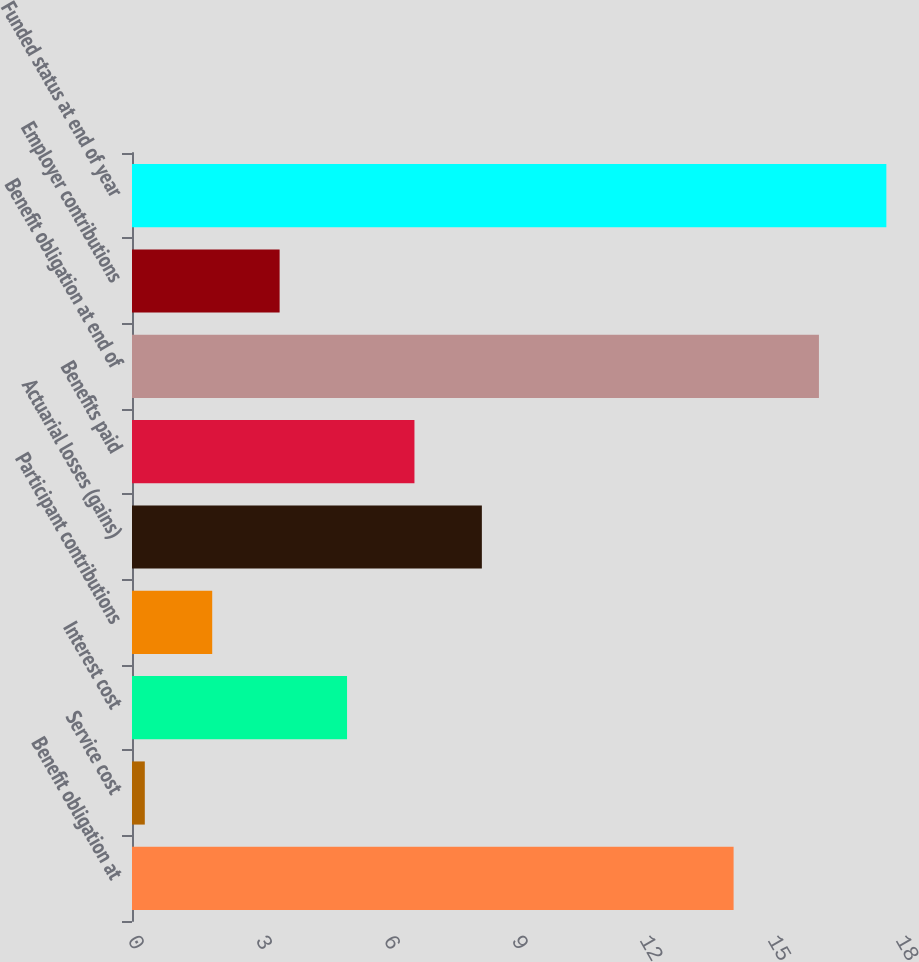<chart> <loc_0><loc_0><loc_500><loc_500><bar_chart><fcel>Benefit obligation at<fcel>Service cost<fcel>Interest cost<fcel>Participant contributions<fcel>Actuarial losses (gains)<fcel>Benefits paid<fcel>Benefit obligation at end of<fcel>Employer contributions<fcel>Funded status at end of year<nl><fcel>14.1<fcel>0.3<fcel>5.04<fcel>1.88<fcel>8.2<fcel>6.62<fcel>16.1<fcel>3.46<fcel>17.68<nl></chart> 